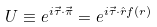<formula> <loc_0><loc_0><loc_500><loc_500>U \equiv e ^ { i \vec { \tau } \cdot \vec { \pi } } = e ^ { i \vec { \tau } \cdot \hat { r } f ( r ) }</formula> 